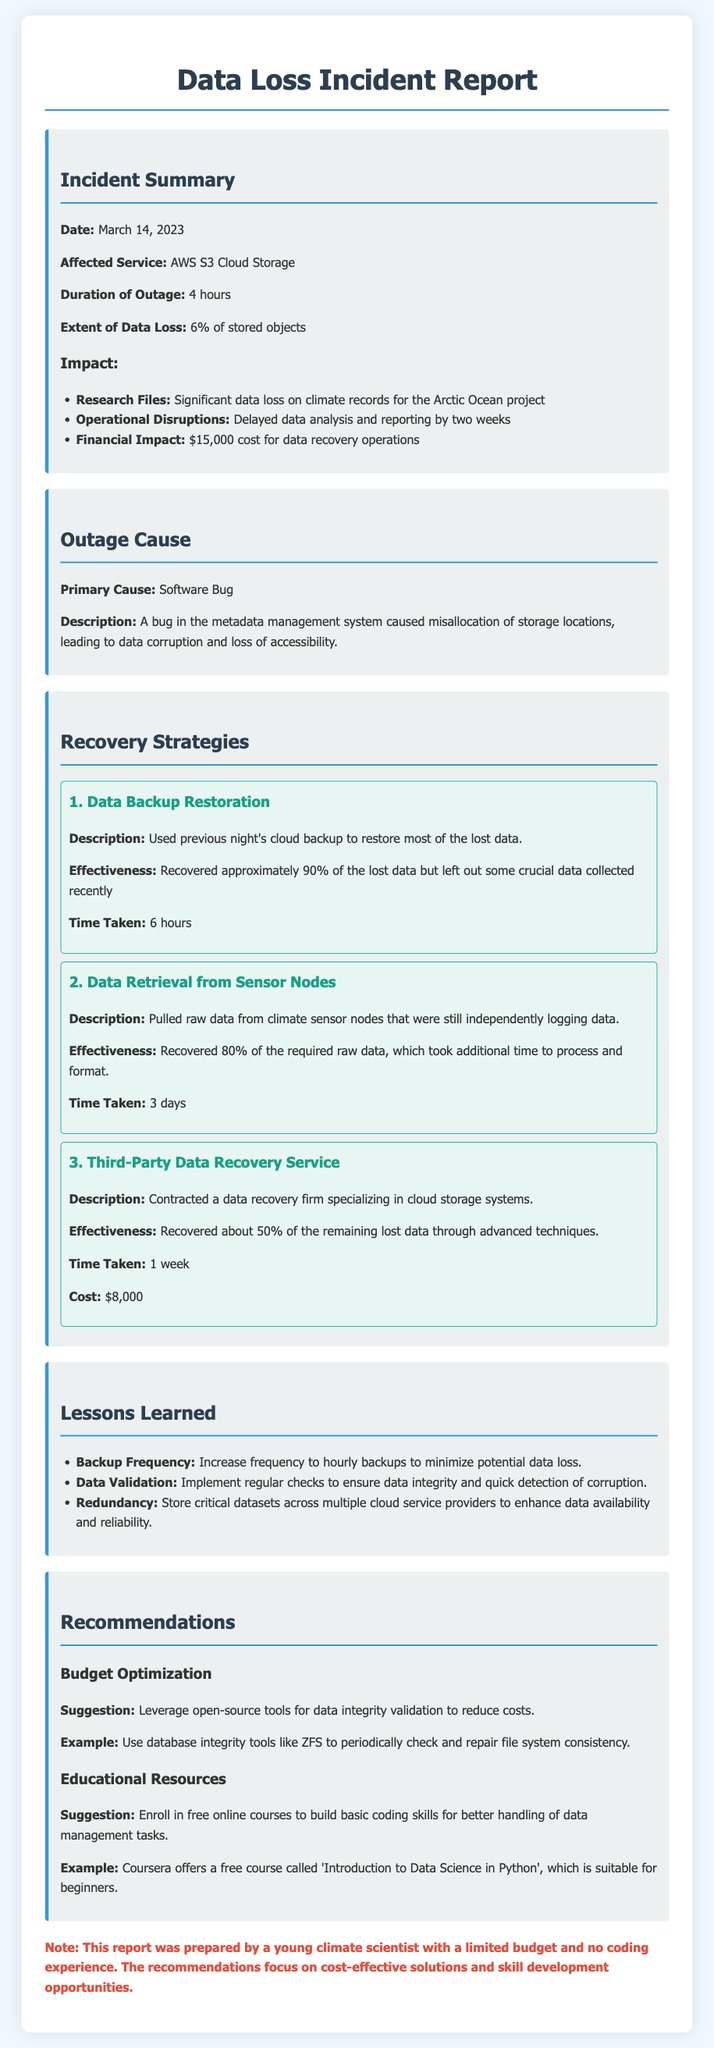What is the date of the incident? The date of the incident is explicitly mentioned in the incident summary section.
Answer: March 14, 2023 How long did the outage last? The duration of the outage is specified as part of the incident summary.
Answer: 4 hours What percentage of data was lost during the incident? The extent of data loss is detailed in the incident summary.
Answer: 6% What was the primary cause of the outage? The primary cause is identified in the outage cause section of the report.
Answer: Software Bug How much did the data recovery operations cost? The financial impact is listed in the incident summary.
Answer: $15,000 Which recovery strategy was the most effective in terms of data recovered? The effectiveness of recovery strategies is mentioned, and overall effectiveness can be deduced from the comparison.
Answer: Data Backup Restoration What are two lessons learned from this incident? The lessons learned are listed in the corresponding section; multiple items can be chosen, focusing on the most relevant.
Answer: Backup Frequency, Data Validation What suggestion is made regarding budget optimization? The recommendations section provides specific suggestions regarding budget optimization.
Answer: Leverage open-source tools How long did it take to recover data using the third-party service? The time taken for each recovery strategy is provided within the recovery strategies section.
Answer: 1 week Which online course is recommended for building coding skills? A specific course is mentioned in the recommendations for educational resources.
Answer: Introduction to Data Science in Python 